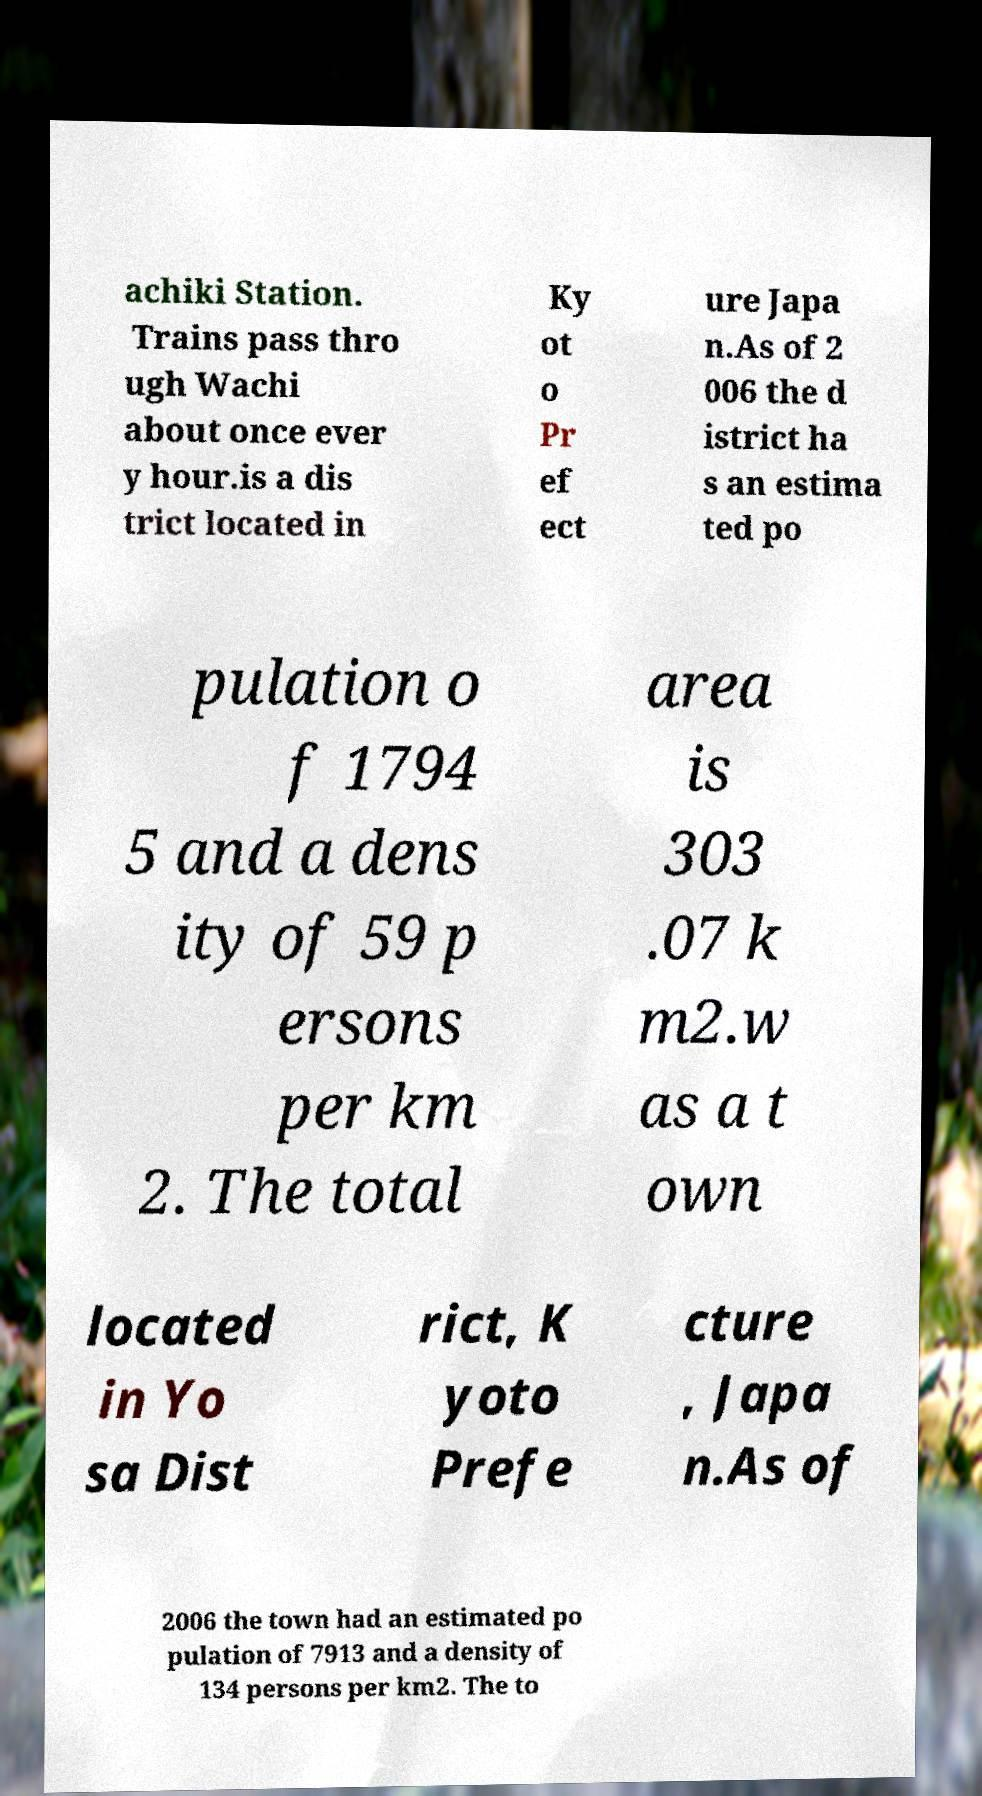Could you assist in decoding the text presented in this image and type it out clearly? achiki Station. Trains pass thro ugh Wachi about once ever y hour.is a dis trict located in Ky ot o Pr ef ect ure Japa n.As of 2 006 the d istrict ha s an estima ted po pulation o f 1794 5 and a dens ity of 59 p ersons per km 2. The total area is 303 .07 k m2.w as a t own located in Yo sa Dist rict, K yoto Prefe cture , Japa n.As of 2006 the town had an estimated po pulation of 7913 and a density of 134 persons per km2. The to 